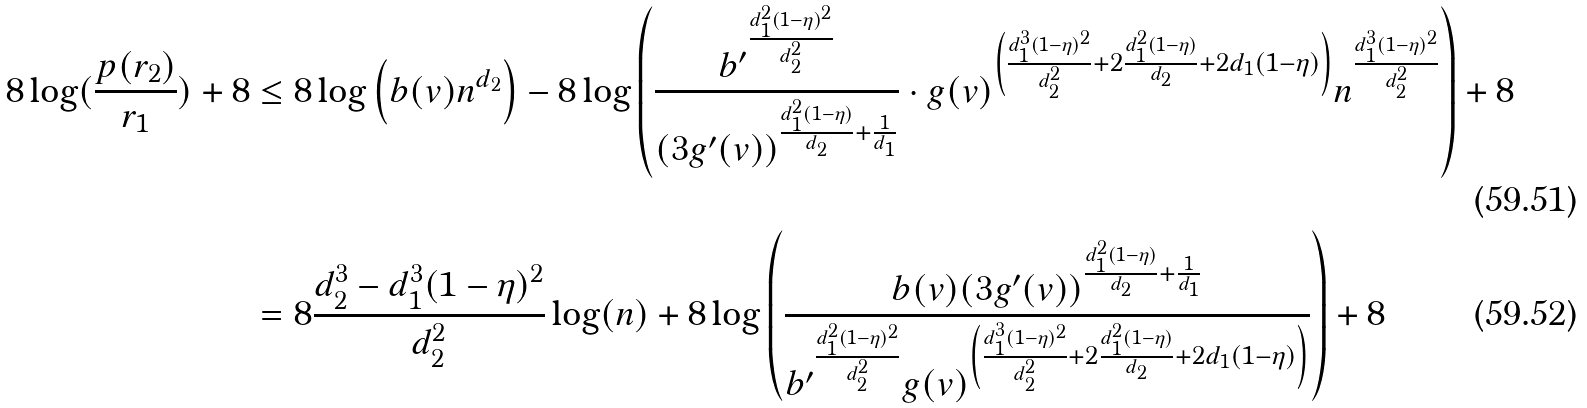Convert formula to latex. <formula><loc_0><loc_0><loc_500><loc_500>8 \log ( \frac { p ( r _ { 2 } ) } { r _ { 1 } } ) + 8 & \leq 8 \log \left ( b ( v ) n ^ { d _ { 2 } } \right ) - 8 \log \left ( \frac { { b ^ { \prime } } ^ { \frac { d _ { 1 } ^ { 2 } ( 1 - \eta ) ^ { 2 } } { d _ { 2 } ^ { 2 } } } } { { ( 3 g ^ { \prime } ( v ) ) } ^ { \frac { d _ { 1 } ^ { 2 } ( 1 - \eta ) } { d _ { 2 } } + \frac { 1 } { d _ { 1 } } } } \cdot g ( v ) ^ { \left ( \frac { d _ { 1 } ^ { 3 } ( 1 - \eta ) ^ { 2 } } { d _ { 2 } ^ { 2 } } + 2 \frac { d _ { 1 } ^ { 2 } ( 1 - \eta ) } { d _ { 2 } } + 2 d _ { 1 } ( 1 - \eta ) \right ) } n ^ { \frac { d _ { 1 } ^ { 3 } ( 1 - \eta ) ^ { 2 } } { d _ { 2 } ^ { 2 } } } \right ) + 8 \\ & = 8 \frac { d _ { 2 } ^ { 3 } - d _ { 1 } ^ { 3 } ( 1 - \eta ) ^ { 2 } } { d _ { 2 } ^ { 2 } } \log ( n ) + 8 \log \left ( \frac { { b ( v ) ( 3 g ^ { \prime } ( v ) ) } ^ { \frac { d _ { 1 } ^ { 2 } ( 1 - \eta ) } { d _ { 2 } } + \frac { 1 } { d _ { 1 } } } } { { b ^ { \prime } } ^ { \frac { d _ { 1 } ^ { 2 } ( 1 - \eta ) ^ { 2 } } { d _ { 2 } ^ { 2 } } } g ( v ) ^ { \left ( \frac { d _ { 1 } ^ { 3 } ( 1 - \eta ) ^ { 2 } } { d _ { 2 } ^ { 2 } } + 2 \frac { d _ { 1 } ^ { 2 } ( 1 - \eta ) } { d _ { 2 } } + 2 d _ { 1 } ( 1 - \eta ) \right ) } } \right ) + 8</formula> 